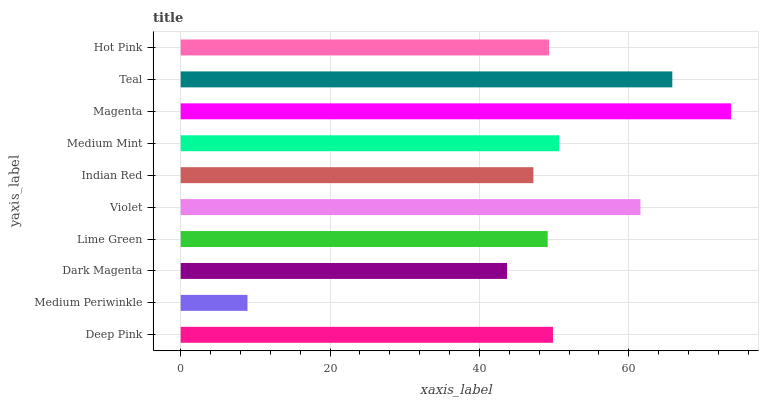Is Medium Periwinkle the minimum?
Answer yes or no. Yes. Is Magenta the maximum?
Answer yes or no. Yes. Is Dark Magenta the minimum?
Answer yes or no. No. Is Dark Magenta the maximum?
Answer yes or no. No. Is Dark Magenta greater than Medium Periwinkle?
Answer yes or no. Yes. Is Medium Periwinkle less than Dark Magenta?
Answer yes or no. Yes. Is Medium Periwinkle greater than Dark Magenta?
Answer yes or no. No. Is Dark Magenta less than Medium Periwinkle?
Answer yes or no. No. Is Deep Pink the high median?
Answer yes or no. Yes. Is Hot Pink the low median?
Answer yes or no. Yes. Is Violet the high median?
Answer yes or no. No. Is Medium Mint the low median?
Answer yes or no. No. 